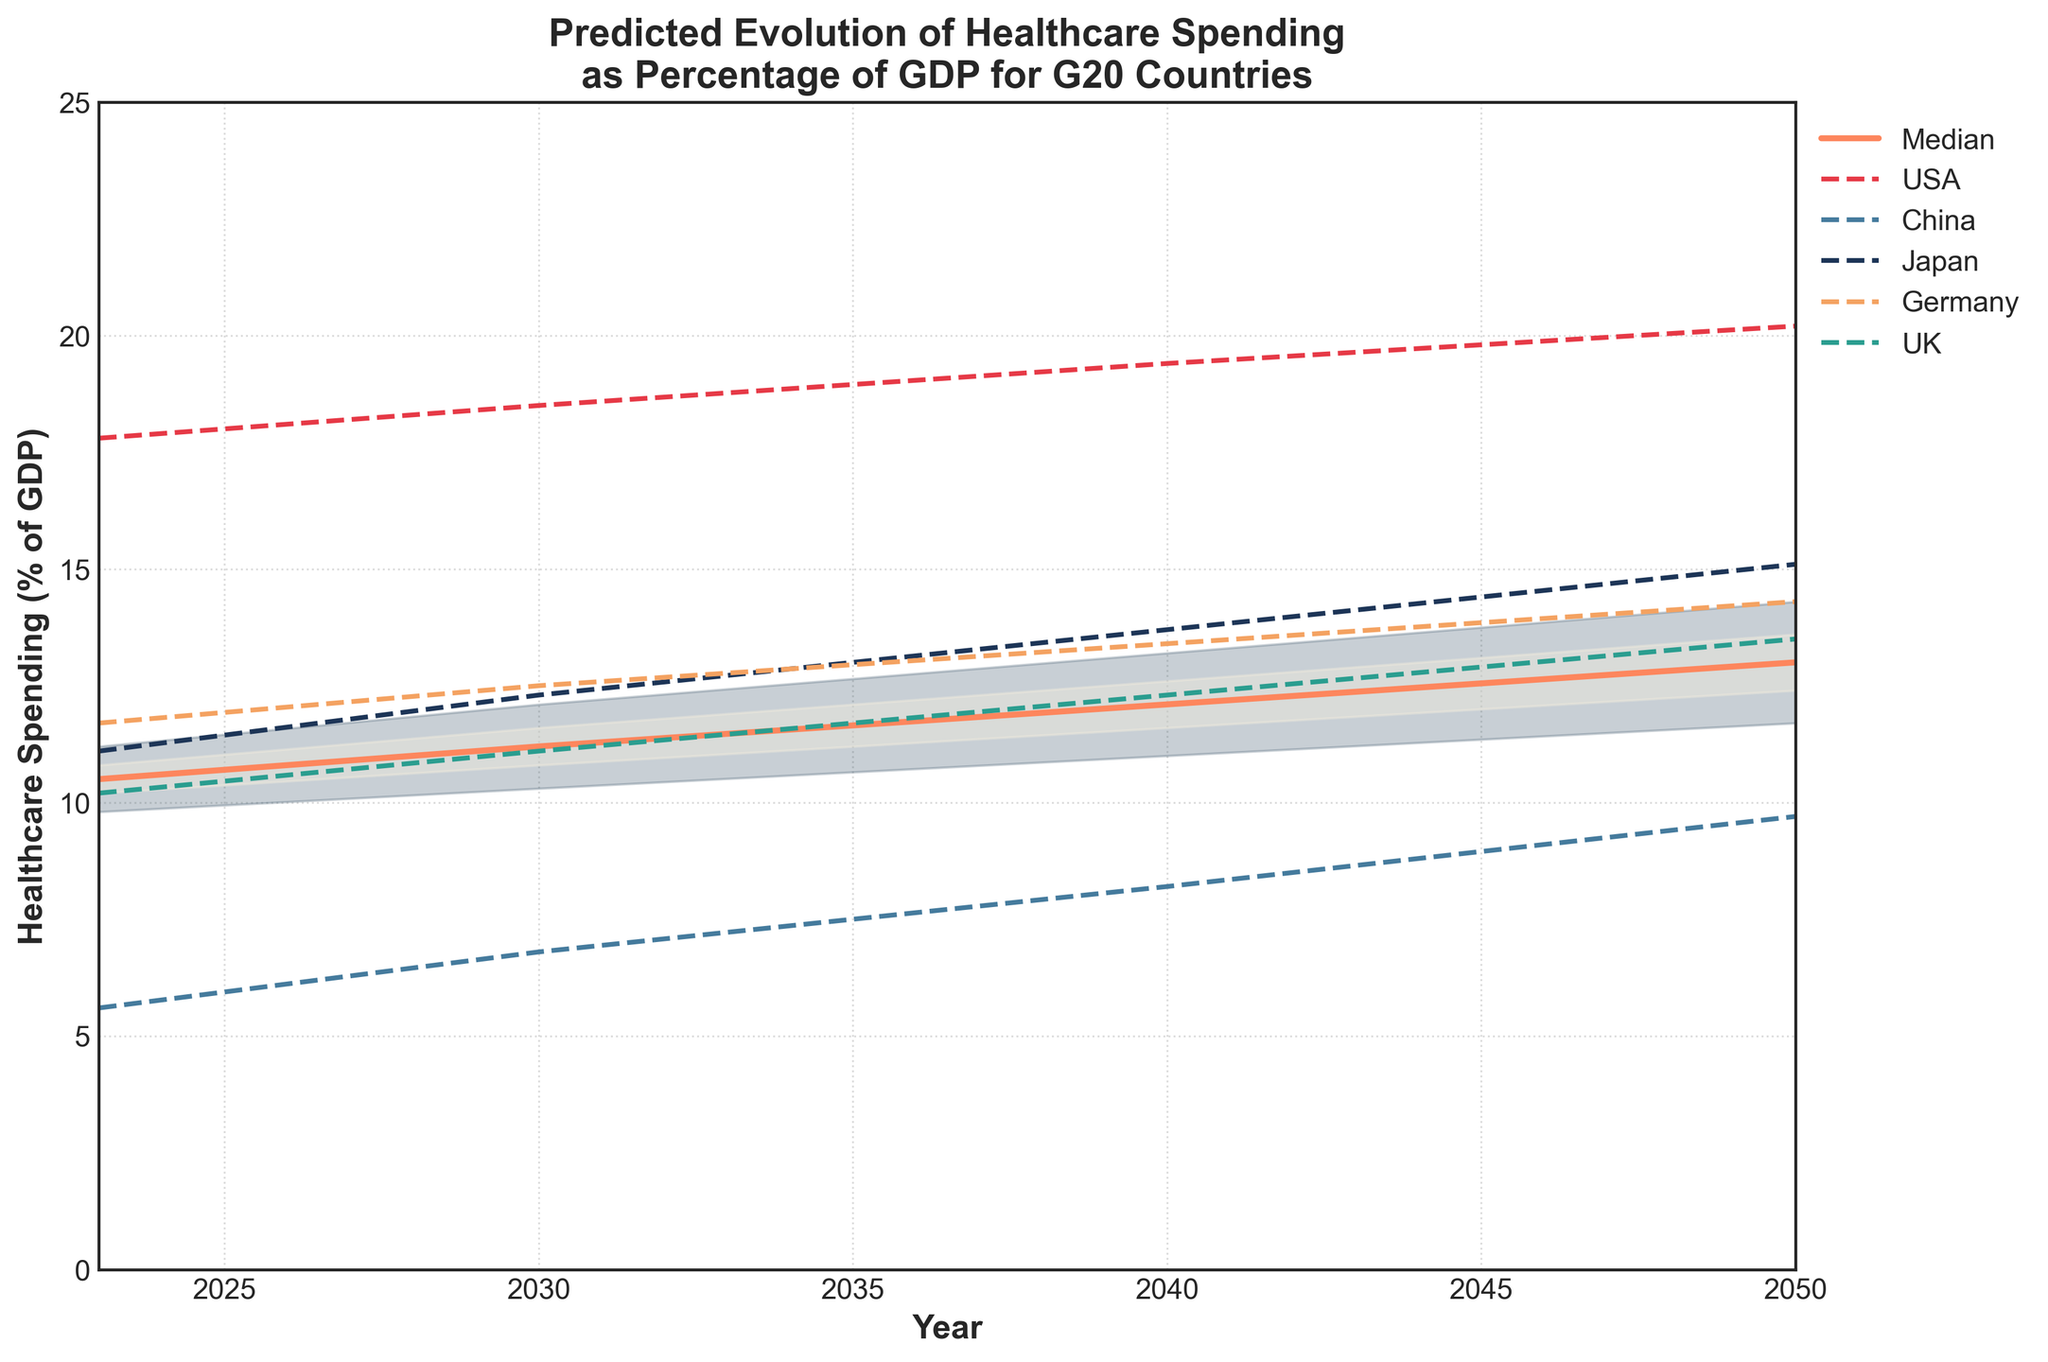What is the title of the figure? The title of the figure is written at the top of the plot and gives an overview of what the chart represents. Here it specifically talks about the predicted evolution of healthcare spending as a percentage of GDP for G20 countries
Answer: Predicted Evolution of Healthcare Spending as Percentage of GDP for G20 Countries Between which years does the plot show data? The x-axis labels outline the range of years depicted in the plot, which is clearly indicated from the first to the last year value.
Answer: 2023 to 2050 Which country is projected to have the highest healthcare spending as a percentage of GDP in 2050? By looking at the plotted lines for each country, find the points corresponding to 2050 and identify the one with the highest value. According to the plot, the line for the USA is the highest in 2050.
Answer: USA What is the median predicted value for healthcare spending as a percentage of GDP in 2030? The median line on the plot represents the median predicted values. At the year 2030 on the x-axis, find the corresponding value on the median line.
Answer: 11.2% How does the upper 90th percentile for healthcare spending in 2050 compare to the median value in the same year? Locate the 2050 year on the x-axis, then check both the upper 90th percentile and the median value on the y-axis. The upper 90th percentile is much higher.
Answer: The upper 90th percentile is higher What is the range of the healthcare spending prediction for 2040 between the 10th and 90th percentiles? For the year 2040, find the values at the lower 10th percentile and the upper 90th percentile. Subtract the lower value from the upper value to get the range. For 2040, these values are 11.0 and 13.2, respectively.
Answer: 2.2% Which country shows the least increase in healthcare spending from 2023 to 2050? Compare the starting and ending points for each country's lines. China's line shows the least increase, going from 5.6 to 9.7.
Answer: China What can be inferred about the trend of healthcare spending in Japan from 2023 to 2050? Observe the line representing Japan to see if it generally increases, decreases, or remains constant over the years. The chart shows an overall increasing trend for Japan’s healthcare spending.
Answer: Increasing trend How do the projected values for the United Kingdom in 2030 compare to the median values of the same year? For 2030, compare the UK’s projected value to the median line’s value at the same year. The UK’s value is 11.1%, which is slightly lower than the median value of 11.2%.
Answer: Slightly lower 